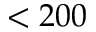<formula> <loc_0><loc_0><loc_500><loc_500>< 2 0 0</formula> 